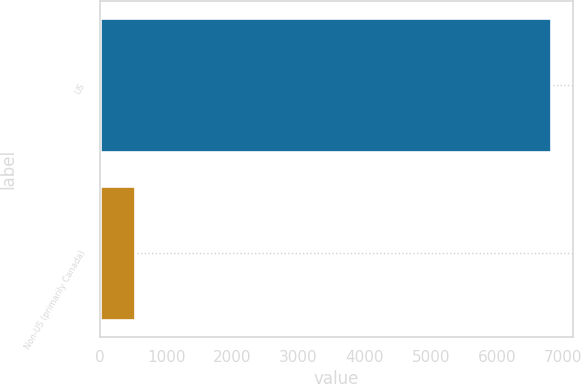<chart> <loc_0><loc_0><loc_500><loc_500><bar_chart><fcel>US<fcel>Non-US (primarily Canada)<nl><fcel>6807.7<fcel>523.8<nl></chart> 